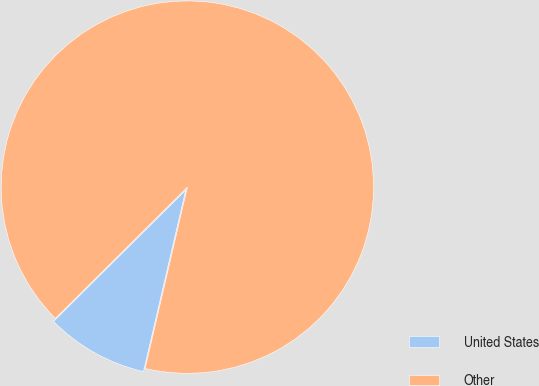Convert chart. <chart><loc_0><loc_0><loc_500><loc_500><pie_chart><fcel>United States<fcel>Other<nl><fcel>8.91%<fcel>91.09%<nl></chart> 